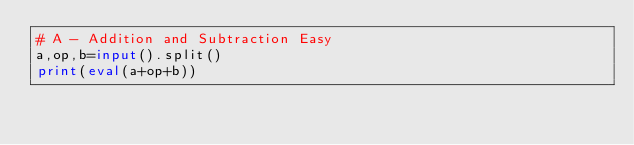Convert code to text. <code><loc_0><loc_0><loc_500><loc_500><_Python_># A - Addition and Subtraction Easy
a,op,b=input().split()
print(eval(a+op+b))

</code> 